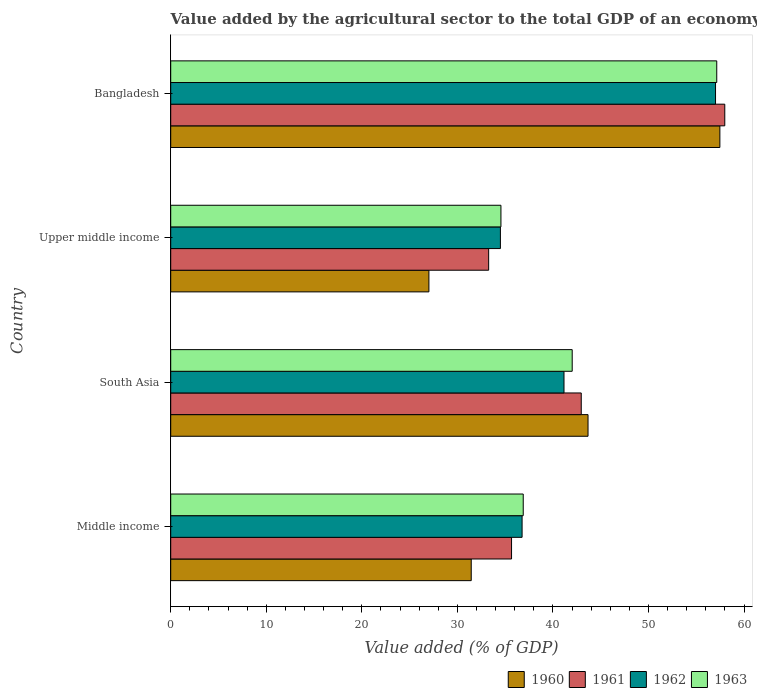How many different coloured bars are there?
Provide a succinct answer. 4. Are the number of bars per tick equal to the number of legend labels?
Offer a very short reply. Yes. Are the number of bars on each tick of the Y-axis equal?
Your answer should be compact. Yes. How many bars are there on the 4th tick from the top?
Ensure brevity in your answer.  4. What is the label of the 3rd group of bars from the top?
Give a very brief answer. South Asia. What is the value added by the agricultural sector to the total GDP in 1963 in Middle income?
Keep it short and to the point. 36.89. Across all countries, what is the maximum value added by the agricultural sector to the total GDP in 1963?
Your answer should be compact. 57.15. Across all countries, what is the minimum value added by the agricultural sector to the total GDP in 1963?
Your answer should be very brief. 34.56. In which country was the value added by the agricultural sector to the total GDP in 1960 maximum?
Your response must be concise. Bangladesh. In which country was the value added by the agricultural sector to the total GDP in 1963 minimum?
Offer a terse response. Upper middle income. What is the total value added by the agricultural sector to the total GDP in 1962 in the graph?
Make the answer very short. 169.46. What is the difference between the value added by the agricultural sector to the total GDP in 1960 in Middle income and that in Upper middle income?
Offer a terse response. 4.43. What is the difference between the value added by the agricultural sector to the total GDP in 1963 in South Asia and the value added by the agricultural sector to the total GDP in 1962 in Upper middle income?
Your response must be concise. 7.52. What is the average value added by the agricultural sector to the total GDP in 1963 per country?
Your answer should be compact. 42.66. What is the difference between the value added by the agricultural sector to the total GDP in 1961 and value added by the agricultural sector to the total GDP in 1963 in Upper middle income?
Your answer should be compact. -1.29. In how many countries, is the value added by the agricultural sector to the total GDP in 1963 greater than 44 %?
Ensure brevity in your answer.  1. What is the ratio of the value added by the agricultural sector to the total GDP in 1962 in South Asia to that in Upper middle income?
Provide a succinct answer. 1.19. What is the difference between the highest and the second highest value added by the agricultural sector to the total GDP in 1961?
Give a very brief answer. 15.02. What is the difference between the highest and the lowest value added by the agricultural sector to the total GDP in 1962?
Provide a short and direct response. 22.51. In how many countries, is the value added by the agricultural sector to the total GDP in 1963 greater than the average value added by the agricultural sector to the total GDP in 1963 taken over all countries?
Offer a very short reply. 1. Is it the case that in every country, the sum of the value added by the agricultural sector to the total GDP in 1963 and value added by the agricultural sector to the total GDP in 1960 is greater than the sum of value added by the agricultural sector to the total GDP in 1962 and value added by the agricultural sector to the total GDP in 1961?
Your response must be concise. No. What is the difference between two consecutive major ticks on the X-axis?
Make the answer very short. 10. Are the values on the major ticks of X-axis written in scientific E-notation?
Provide a succinct answer. No. Does the graph contain any zero values?
Your answer should be compact. No. Where does the legend appear in the graph?
Your response must be concise. Bottom right. What is the title of the graph?
Offer a terse response. Value added by the agricultural sector to the total GDP of an economy. What is the label or title of the X-axis?
Keep it short and to the point. Value added (% of GDP). What is the Value added (% of GDP) in 1960 in Middle income?
Offer a terse response. 31.45. What is the Value added (% of GDP) in 1961 in Middle income?
Your answer should be very brief. 35.67. What is the Value added (% of GDP) of 1962 in Middle income?
Your answer should be compact. 36.77. What is the Value added (% of GDP) of 1963 in Middle income?
Keep it short and to the point. 36.89. What is the Value added (% of GDP) of 1960 in South Asia?
Provide a short and direct response. 43.68. What is the Value added (% of GDP) of 1961 in South Asia?
Provide a short and direct response. 42.96. What is the Value added (% of GDP) in 1962 in South Asia?
Provide a short and direct response. 41.16. What is the Value added (% of GDP) in 1963 in South Asia?
Ensure brevity in your answer.  42.02. What is the Value added (% of GDP) of 1960 in Upper middle income?
Your answer should be compact. 27.02. What is the Value added (% of GDP) of 1961 in Upper middle income?
Give a very brief answer. 33.27. What is the Value added (% of GDP) of 1962 in Upper middle income?
Offer a terse response. 34.5. What is the Value added (% of GDP) of 1963 in Upper middle income?
Ensure brevity in your answer.  34.56. What is the Value added (% of GDP) of 1960 in Bangladesh?
Keep it short and to the point. 57.47. What is the Value added (% of GDP) of 1961 in Bangladesh?
Your answer should be compact. 57.99. What is the Value added (% of GDP) of 1962 in Bangladesh?
Your answer should be compact. 57.02. What is the Value added (% of GDP) in 1963 in Bangladesh?
Offer a very short reply. 57.15. Across all countries, what is the maximum Value added (% of GDP) in 1960?
Offer a terse response. 57.47. Across all countries, what is the maximum Value added (% of GDP) of 1961?
Make the answer very short. 57.99. Across all countries, what is the maximum Value added (% of GDP) in 1962?
Provide a succinct answer. 57.02. Across all countries, what is the maximum Value added (% of GDP) of 1963?
Your answer should be very brief. 57.15. Across all countries, what is the minimum Value added (% of GDP) of 1960?
Provide a succinct answer. 27.02. Across all countries, what is the minimum Value added (% of GDP) in 1961?
Ensure brevity in your answer.  33.27. Across all countries, what is the minimum Value added (% of GDP) in 1962?
Your response must be concise. 34.5. Across all countries, what is the minimum Value added (% of GDP) of 1963?
Provide a succinct answer. 34.56. What is the total Value added (% of GDP) of 1960 in the graph?
Your answer should be compact. 159.62. What is the total Value added (% of GDP) of 1961 in the graph?
Offer a terse response. 169.9. What is the total Value added (% of GDP) in 1962 in the graph?
Provide a succinct answer. 169.46. What is the total Value added (% of GDP) in 1963 in the graph?
Give a very brief answer. 170.62. What is the difference between the Value added (% of GDP) of 1960 in Middle income and that in South Asia?
Your answer should be compact. -12.22. What is the difference between the Value added (% of GDP) in 1961 in Middle income and that in South Asia?
Offer a terse response. -7.29. What is the difference between the Value added (% of GDP) of 1962 in Middle income and that in South Asia?
Keep it short and to the point. -4.39. What is the difference between the Value added (% of GDP) in 1963 in Middle income and that in South Asia?
Offer a terse response. -5.13. What is the difference between the Value added (% of GDP) in 1960 in Middle income and that in Upper middle income?
Your response must be concise. 4.43. What is the difference between the Value added (% of GDP) in 1961 in Middle income and that in Upper middle income?
Provide a succinct answer. 2.4. What is the difference between the Value added (% of GDP) in 1962 in Middle income and that in Upper middle income?
Offer a very short reply. 2.27. What is the difference between the Value added (% of GDP) of 1963 in Middle income and that in Upper middle income?
Give a very brief answer. 2.33. What is the difference between the Value added (% of GDP) of 1960 in Middle income and that in Bangladesh?
Give a very brief answer. -26.02. What is the difference between the Value added (% of GDP) in 1961 in Middle income and that in Bangladesh?
Your answer should be very brief. -22.32. What is the difference between the Value added (% of GDP) in 1962 in Middle income and that in Bangladesh?
Provide a succinct answer. -20.24. What is the difference between the Value added (% of GDP) in 1963 in Middle income and that in Bangladesh?
Your answer should be compact. -20.25. What is the difference between the Value added (% of GDP) in 1960 in South Asia and that in Upper middle income?
Your response must be concise. 16.65. What is the difference between the Value added (% of GDP) in 1961 in South Asia and that in Upper middle income?
Your answer should be compact. 9.69. What is the difference between the Value added (% of GDP) in 1962 in South Asia and that in Upper middle income?
Provide a succinct answer. 6.66. What is the difference between the Value added (% of GDP) of 1963 in South Asia and that in Upper middle income?
Make the answer very short. 7.46. What is the difference between the Value added (% of GDP) in 1960 in South Asia and that in Bangladesh?
Provide a succinct answer. -13.8. What is the difference between the Value added (% of GDP) of 1961 in South Asia and that in Bangladesh?
Your answer should be compact. -15.02. What is the difference between the Value added (% of GDP) of 1962 in South Asia and that in Bangladesh?
Offer a terse response. -15.86. What is the difference between the Value added (% of GDP) of 1963 in South Asia and that in Bangladesh?
Offer a terse response. -15.13. What is the difference between the Value added (% of GDP) in 1960 in Upper middle income and that in Bangladesh?
Offer a terse response. -30.45. What is the difference between the Value added (% of GDP) in 1961 in Upper middle income and that in Bangladesh?
Ensure brevity in your answer.  -24.71. What is the difference between the Value added (% of GDP) of 1962 in Upper middle income and that in Bangladesh?
Offer a terse response. -22.51. What is the difference between the Value added (% of GDP) of 1963 in Upper middle income and that in Bangladesh?
Offer a terse response. -22.59. What is the difference between the Value added (% of GDP) of 1960 in Middle income and the Value added (% of GDP) of 1961 in South Asia?
Provide a succinct answer. -11.51. What is the difference between the Value added (% of GDP) in 1960 in Middle income and the Value added (% of GDP) in 1962 in South Asia?
Offer a terse response. -9.71. What is the difference between the Value added (% of GDP) of 1960 in Middle income and the Value added (% of GDP) of 1963 in South Asia?
Your response must be concise. -10.57. What is the difference between the Value added (% of GDP) of 1961 in Middle income and the Value added (% of GDP) of 1962 in South Asia?
Your response must be concise. -5.49. What is the difference between the Value added (% of GDP) in 1961 in Middle income and the Value added (% of GDP) in 1963 in South Asia?
Ensure brevity in your answer.  -6.35. What is the difference between the Value added (% of GDP) in 1962 in Middle income and the Value added (% of GDP) in 1963 in South Asia?
Offer a very short reply. -5.25. What is the difference between the Value added (% of GDP) of 1960 in Middle income and the Value added (% of GDP) of 1961 in Upper middle income?
Give a very brief answer. -1.82. What is the difference between the Value added (% of GDP) of 1960 in Middle income and the Value added (% of GDP) of 1962 in Upper middle income?
Offer a terse response. -3.05. What is the difference between the Value added (% of GDP) in 1960 in Middle income and the Value added (% of GDP) in 1963 in Upper middle income?
Give a very brief answer. -3.11. What is the difference between the Value added (% of GDP) in 1961 in Middle income and the Value added (% of GDP) in 1962 in Upper middle income?
Keep it short and to the point. 1.17. What is the difference between the Value added (% of GDP) of 1961 in Middle income and the Value added (% of GDP) of 1963 in Upper middle income?
Give a very brief answer. 1.11. What is the difference between the Value added (% of GDP) in 1962 in Middle income and the Value added (% of GDP) in 1963 in Upper middle income?
Offer a very short reply. 2.21. What is the difference between the Value added (% of GDP) of 1960 in Middle income and the Value added (% of GDP) of 1961 in Bangladesh?
Offer a terse response. -26.54. What is the difference between the Value added (% of GDP) of 1960 in Middle income and the Value added (% of GDP) of 1962 in Bangladesh?
Keep it short and to the point. -25.57. What is the difference between the Value added (% of GDP) of 1960 in Middle income and the Value added (% of GDP) of 1963 in Bangladesh?
Provide a short and direct response. -25.7. What is the difference between the Value added (% of GDP) of 1961 in Middle income and the Value added (% of GDP) of 1962 in Bangladesh?
Offer a terse response. -21.35. What is the difference between the Value added (% of GDP) of 1961 in Middle income and the Value added (% of GDP) of 1963 in Bangladesh?
Your response must be concise. -21.48. What is the difference between the Value added (% of GDP) of 1962 in Middle income and the Value added (% of GDP) of 1963 in Bangladesh?
Ensure brevity in your answer.  -20.37. What is the difference between the Value added (% of GDP) of 1960 in South Asia and the Value added (% of GDP) of 1961 in Upper middle income?
Your response must be concise. 10.4. What is the difference between the Value added (% of GDP) in 1960 in South Asia and the Value added (% of GDP) in 1962 in Upper middle income?
Your answer should be very brief. 9.17. What is the difference between the Value added (% of GDP) in 1960 in South Asia and the Value added (% of GDP) in 1963 in Upper middle income?
Keep it short and to the point. 9.11. What is the difference between the Value added (% of GDP) in 1961 in South Asia and the Value added (% of GDP) in 1962 in Upper middle income?
Your response must be concise. 8.46. What is the difference between the Value added (% of GDP) in 1961 in South Asia and the Value added (% of GDP) in 1963 in Upper middle income?
Provide a short and direct response. 8.4. What is the difference between the Value added (% of GDP) of 1962 in South Asia and the Value added (% of GDP) of 1963 in Upper middle income?
Give a very brief answer. 6.6. What is the difference between the Value added (% of GDP) of 1960 in South Asia and the Value added (% of GDP) of 1961 in Bangladesh?
Make the answer very short. -14.31. What is the difference between the Value added (% of GDP) of 1960 in South Asia and the Value added (% of GDP) of 1962 in Bangladesh?
Your answer should be compact. -13.34. What is the difference between the Value added (% of GDP) in 1960 in South Asia and the Value added (% of GDP) in 1963 in Bangladesh?
Give a very brief answer. -13.47. What is the difference between the Value added (% of GDP) in 1961 in South Asia and the Value added (% of GDP) in 1962 in Bangladesh?
Provide a short and direct response. -14.05. What is the difference between the Value added (% of GDP) of 1961 in South Asia and the Value added (% of GDP) of 1963 in Bangladesh?
Your response must be concise. -14.18. What is the difference between the Value added (% of GDP) in 1962 in South Asia and the Value added (% of GDP) in 1963 in Bangladesh?
Your response must be concise. -15.99. What is the difference between the Value added (% of GDP) in 1960 in Upper middle income and the Value added (% of GDP) in 1961 in Bangladesh?
Give a very brief answer. -30.97. What is the difference between the Value added (% of GDP) of 1960 in Upper middle income and the Value added (% of GDP) of 1962 in Bangladesh?
Your answer should be very brief. -30. What is the difference between the Value added (% of GDP) in 1960 in Upper middle income and the Value added (% of GDP) in 1963 in Bangladesh?
Make the answer very short. -30.12. What is the difference between the Value added (% of GDP) of 1961 in Upper middle income and the Value added (% of GDP) of 1962 in Bangladesh?
Keep it short and to the point. -23.74. What is the difference between the Value added (% of GDP) of 1961 in Upper middle income and the Value added (% of GDP) of 1963 in Bangladesh?
Keep it short and to the point. -23.87. What is the difference between the Value added (% of GDP) in 1962 in Upper middle income and the Value added (% of GDP) in 1963 in Bangladesh?
Ensure brevity in your answer.  -22.64. What is the average Value added (% of GDP) in 1960 per country?
Your answer should be compact. 39.91. What is the average Value added (% of GDP) of 1961 per country?
Offer a terse response. 42.47. What is the average Value added (% of GDP) of 1962 per country?
Your answer should be compact. 42.36. What is the average Value added (% of GDP) of 1963 per country?
Give a very brief answer. 42.66. What is the difference between the Value added (% of GDP) of 1960 and Value added (% of GDP) of 1961 in Middle income?
Your answer should be compact. -4.22. What is the difference between the Value added (% of GDP) of 1960 and Value added (% of GDP) of 1962 in Middle income?
Your answer should be very brief. -5.32. What is the difference between the Value added (% of GDP) of 1960 and Value added (% of GDP) of 1963 in Middle income?
Your answer should be very brief. -5.44. What is the difference between the Value added (% of GDP) of 1961 and Value added (% of GDP) of 1962 in Middle income?
Your response must be concise. -1.1. What is the difference between the Value added (% of GDP) of 1961 and Value added (% of GDP) of 1963 in Middle income?
Make the answer very short. -1.22. What is the difference between the Value added (% of GDP) in 1962 and Value added (% of GDP) in 1963 in Middle income?
Provide a succinct answer. -0.12. What is the difference between the Value added (% of GDP) in 1960 and Value added (% of GDP) in 1961 in South Asia?
Offer a very short reply. 0.71. What is the difference between the Value added (% of GDP) in 1960 and Value added (% of GDP) in 1962 in South Asia?
Your answer should be very brief. 2.52. What is the difference between the Value added (% of GDP) of 1960 and Value added (% of GDP) of 1963 in South Asia?
Your answer should be very brief. 1.66. What is the difference between the Value added (% of GDP) of 1961 and Value added (% of GDP) of 1962 in South Asia?
Provide a succinct answer. 1.8. What is the difference between the Value added (% of GDP) in 1961 and Value added (% of GDP) in 1963 in South Asia?
Your answer should be compact. 0.95. What is the difference between the Value added (% of GDP) in 1962 and Value added (% of GDP) in 1963 in South Asia?
Offer a terse response. -0.86. What is the difference between the Value added (% of GDP) of 1960 and Value added (% of GDP) of 1961 in Upper middle income?
Offer a terse response. -6.25. What is the difference between the Value added (% of GDP) in 1960 and Value added (% of GDP) in 1962 in Upper middle income?
Make the answer very short. -7.48. What is the difference between the Value added (% of GDP) of 1960 and Value added (% of GDP) of 1963 in Upper middle income?
Make the answer very short. -7.54. What is the difference between the Value added (% of GDP) of 1961 and Value added (% of GDP) of 1962 in Upper middle income?
Ensure brevity in your answer.  -1.23. What is the difference between the Value added (% of GDP) of 1961 and Value added (% of GDP) of 1963 in Upper middle income?
Your response must be concise. -1.29. What is the difference between the Value added (% of GDP) in 1962 and Value added (% of GDP) in 1963 in Upper middle income?
Provide a succinct answer. -0.06. What is the difference between the Value added (% of GDP) of 1960 and Value added (% of GDP) of 1961 in Bangladesh?
Give a very brief answer. -0.51. What is the difference between the Value added (% of GDP) of 1960 and Value added (% of GDP) of 1962 in Bangladesh?
Your response must be concise. 0.46. What is the difference between the Value added (% of GDP) of 1960 and Value added (% of GDP) of 1963 in Bangladesh?
Keep it short and to the point. 0.33. What is the difference between the Value added (% of GDP) of 1961 and Value added (% of GDP) of 1962 in Bangladesh?
Ensure brevity in your answer.  0.97. What is the difference between the Value added (% of GDP) of 1961 and Value added (% of GDP) of 1963 in Bangladesh?
Your answer should be compact. 0.84. What is the difference between the Value added (% of GDP) in 1962 and Value added (% of GDP) in 1963 in Bangladesh?
Provide a short and direct response. -0.13. What is the ratio of the Value added (% of GDP) of 1960 in Middle income to that in South Asia?
Your answer should be compact. 0.72. What is the ratio of the Value added (% of GDP) in 1961 in Middle income to that in South Asia?
Your answer should be compact. 0.83. What is the ratio of the Value added (% of GDP) of 1962 in Middle income to that in South Asia?
Provide a short and direct response. 0.89. What is the ratio of the Value added (% of GDP) of 1963 in Middle income to that in South Asia?
Offer a very short reply. 0.88. What is the ratio of the Value added (% of GDP) of 1960 in Middle income to that in Upper middle income?
Keep it short and to the point. 1.16. What is the ratio of the Value added (% of GDP) in 1961 in Middle income to that in Upper middle income?
Keep it short and to the point. 1.07. What is the ratio of the Value added (% of GDP) of 1962 in Middle income to that in Upper middle income?
Your response must be concise. 1.07. What is the ratio of the Value added (% of GDP) in 1963 in Middle income to that in Upper middle income?
Offer a very short reply. 1.07. What is the ratio of the Value added (% of GDP) of 1960 in Middle income to that in Bangladesh?
Provide a succinct answer. 0.55. What is the ratio of the Value added (% of GDP) in 1961 in Middle income to that in Bangladesh?
Your answer should be very brief. 0.62. What is the ratio of the Value added (% of GDP) of 1962 in Middle income to that in Bangladesh?
Provide a succinct answer. 0.64. What is the ratio of the Value added (% of GDP) of 1963 in Middle income to that in Bangladesh?
Ensure brevity in your answer.  0.65. What is the ratio of the Value added (% of GDP) in 1960 in South Asia to that in Upper middle income?
Ensure brevity in your answer.  1.62. What is the ratio of the Value added (% of GDP) of 1961 in South Asia to that in Upper middle income?
Ensure brevity in your answer.  1.29. What is the ratio of the Value added (% of GDP) of 1962 in South Asia to that in Upper middle income?
Make the answer very short. 1.19. What is the ratio of the Value added (% of GDP) of 1963 in South Asia to that in Upper middle income?
Offer a terse response. 1.22. What is the ratio of the Value added (% of GDP) in 1960 in South Asia to that in Bangladesh?
Ensure brevity in your answer.  0.76. What is the ratio of the Value added (% of GDP) in 1961 in South Asia to that in Bangladesh?
Provide a succinct answer. 0.74. What is the ratio of the Value added (% of GDP) of 1962 in South Asia to that in Bangladesh?
Ensure brevity in your answer.  0.72. What is the ratio of the Value added (% of GDP) of 1963 in South Asia to that in Bangladesh?
Your answer should be compact. 0.74. What is the ratio of the Value added (% of GDP) of 1960 in Upper middle income to that in Bangladesh?
Your response must be concise. 0.47. What is the ratio of the Value added (% of GDP) of 1961 in Upper middle income to that in Bangladesh?
Offer a very short reply. 0.57. What is the ratio of the Value added (% of GDP) of 1962 in Upper middle income to that in Bangladesh?
Offer a very short reply. 0.61. What is the ratio of the Value added (% of GDP) of 1963 in Upper middle income to that in Bangladesh?
Your answer should be compact. 0.6. What is the difference between the highest and the second highest Value added (% of GDP) in 1960?
Your response must be concise. 13.8. What is the difference between the highest and the second highest Value added (% of GDP) in 1961?
Your response must be concise. 15.02. What is the difference between the highest and the second highest Value added (% of GDP) in 1962?
Keep it short and to the point. 15.86. What is the difference between the highest and the second highest Value added (% of GDP) in 1963?
Your response must be concise. 15.13. What is the difference between the highest and the lowest Value added (% of GDP) in 1960?
Your answer should be very brief. 30.45. What is the difference between the highest and the lowest Value added (% of GDP) of 1961?
Ensure brevity in your answer.  24.71. What is the difference between the highest and the lowest Value added (% of GDP) of 1962?
Your answer should be very brief. 22.51. What is the difference between the highest and the lowest Value added (% of GDP) of 1963?
Your answer should be compact. 22.59. 